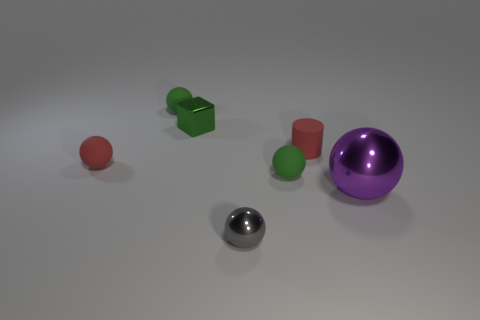Are there fewer gray objects than small purple metal cubes?
Provide a short and direct response. No. There is a small red object to the right of the green ball that is in front of the red cylinder; what number of tiny red objects are on the left side of it?
Keep it short and to the point. 1. There is a sphere behind the tiny green shiny block; what size is it?
Ensure brevity in your answer.  Small. There is a small green rubber thing on the right side of the gray shiny thing; does it have the same shape as the small gray thing?
Make the answer very short. Yes. What material is the big purple thing that is the same shape as the gray thing?
Ensure brevity in your answer.  Metal. Is there any other thing that is the same size as the purple metallic thing?
Keep it short and to the point. No. Are any big gray metal cylinders visible?
Give a very brief answer. No. There is a green sphere that is on the left side of the green rubber object in front of the small sphere that is behind the block; what is its material?
Offer a very short reply. Rubber. There is a purple object; does it have the same shape as the small thing in front of the big purple shiny object?
Your response must be concise. Yes. What number of small red things are the same shape as the big purple thing?
Your answer should be compact. 1. 